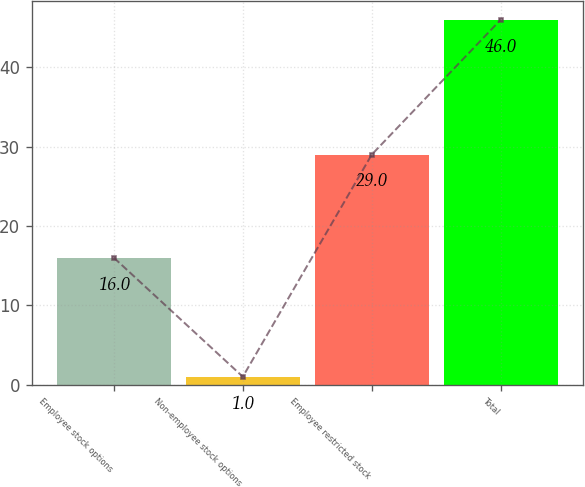Convert chart. <chart><loc_0><loc_0><loc_500><loc_500><bar_chart><fcel>Employee stock options<fcel>Non-employee stock options<fcel>Employee restricted stock<fcel>Total<nl><fcel>16<fcel>1<fcel>29<fcel>46<nl></chart> 